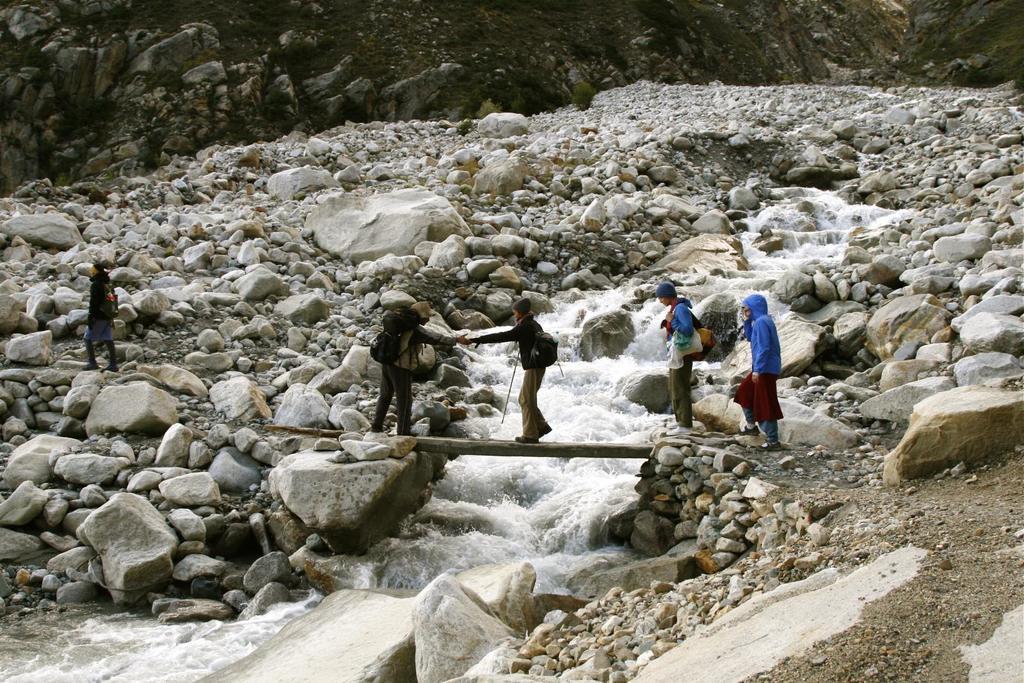Describe this image in one or two sentences. On the left side, there is a person walking on the path. There is a person walking on a wood and is giving hand to the other person who is standing. There are two persons near this wood. And this wood is on the water fall. On both sides of this water fall, there are stones and rocks. In the background, there is a mountain. 